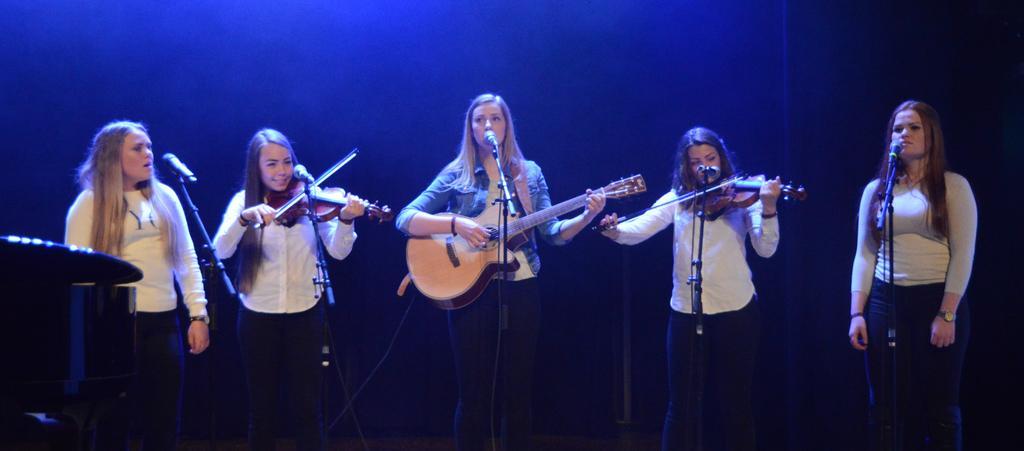Describe this image in one or two sentences. In this image I can see few women were three of them playing musical instruments. I can also see mice in front of everyone. 